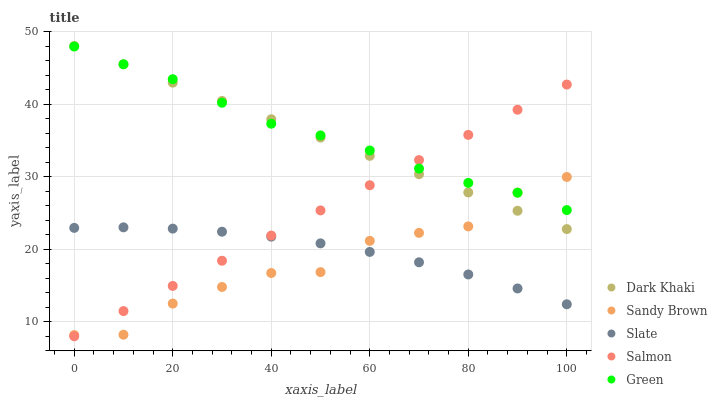Does Sandy Brown have the minimum area under the curve?
Answer yes or no. Yes. Does Green have the maximum area under the curve?
Answer yes or no. Yes. Does Salmon have the minimum area under the curve?
Answer yes or no. No. Does Salmon have the maximum area under the curve?
Answer yes or no. No. Is Salmon the smoothest?
Answer yes or no. Yes. Is Sandy Brown the roughest?
Answer yes or no. Yes. Is Slate the smoothest?
Answer yes or no. No. Is Slate the roughest?
Answer yes or no. No. Does Salmon have the lowest value?
Answer yes or no. Yes. Does Slate have the lowest value?
Answer yes or no. No. Does Dark Khaki have the highest value?
Answer yes or no. Yes. Does Salmon have the highest value?
Answer yes or no. No. Is Slate less than Dark Khaki?
Answer yes or no. Yes. Is Green greater than Slate?
Answer yes or no. Yes. Does Dark Khaki intersect Green?
Answer yes or no. Yes. Is Dark Khaki less than Green?
Answer yes or no. No. Is Dark Khaki greater than Green?
Answer yes or no. No. Does Slate intersect Dark Khaki?
Answer yes or no. No. 